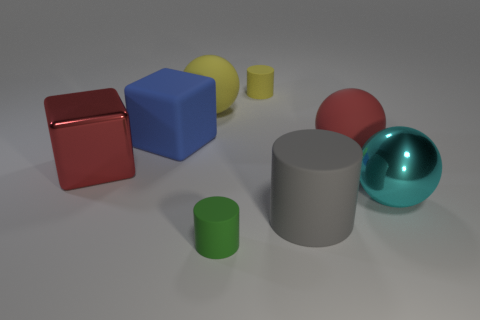The cyan object that is the same size as the red rubber object is what shape?
Make the answer very short. Sphere. What is the shape of the big gray object?
Give a very brief answer. Cylinder. Is the material of the small cylinder in front of the tiny yellow rubber thing the same as the tiny yellow thing?
Keep it short and to the point. Yes. What is the size of the metal block that is to the left of the small object in front of the large yellow matte object?
Your answer should be very brief. Large. There is a ball that is both on the right side of the small green cylinder and on the left side of the large cyan metallic thing; what color is it?
Your answer should be very brief. Red. There is a yellow cylinder that is the same size as the green rubber thing; what is it made of?
Keep it short and to the point. Rubber. How many other things are the same material as the red ball?
Provide a short and direct response. 5. Is the color of the matte ball that is in front of the blue matte cube the same as the shiny thing on the left side of the big yellow object?
Provide a succinct answer. Yes. There is a small rubber thing that is behind the big rubber ball right of the large gray matte cylinder; what is its shape?
Your answer should be compact. Cylinder. How many other things are there of the same color as the big metallic block?
Ensure brevity in your answer.  1. 